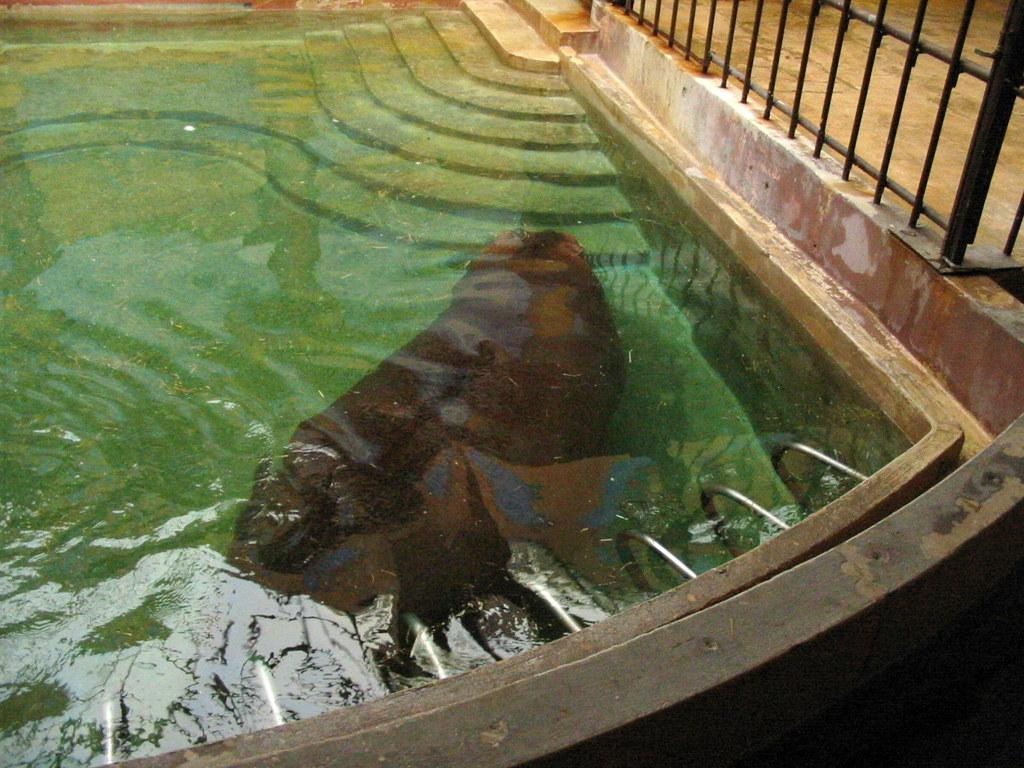What type of animal can be seen in the water pond in the image? There is a sea animal in the water pond in the image. What architectural feature is visible in the background? There are steps in the background. What other elements can be seen in the background? There is a fencing and a road in the background. Can you tell me how many pages the book being printed by the lake in the image has? There is no book or lake present in the image, so it is not possible to answer that question. 